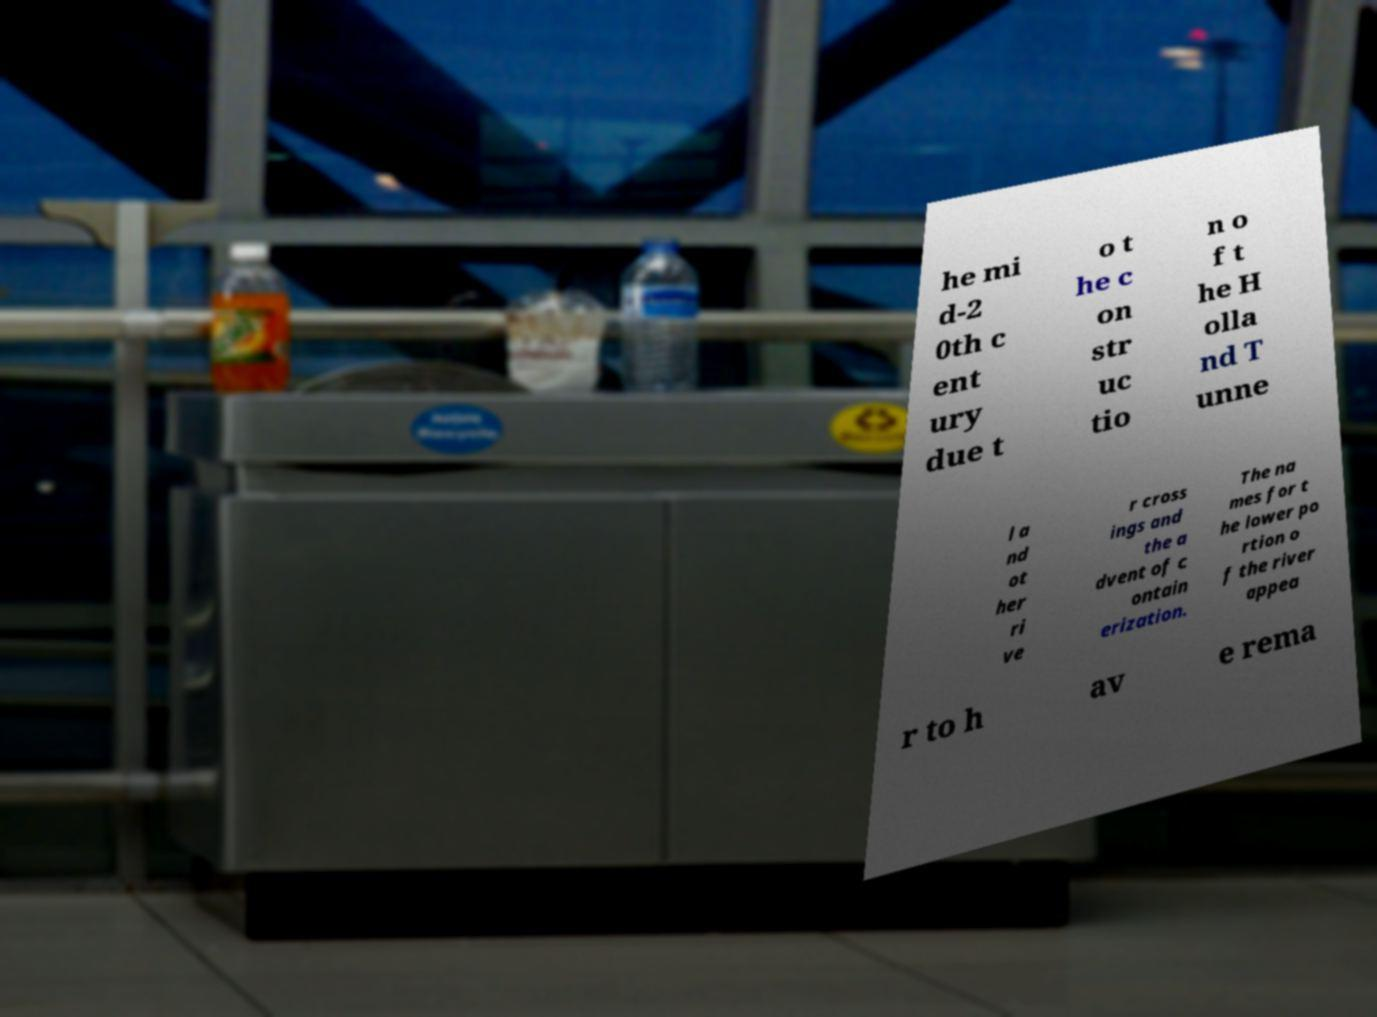Can you read and provide the text displayed in the image?This photo seems to have some interesting text. Can you extract and type it out for me? he mi d-2 0th c ent ury due t o t he c on str uc tio n o f t he H olla nd T unne l a nd ot her ri ve r cross ings and the a dvent of c ontain erization. The na mes for t he lower po rtion o f the river appea r to h av e rema 